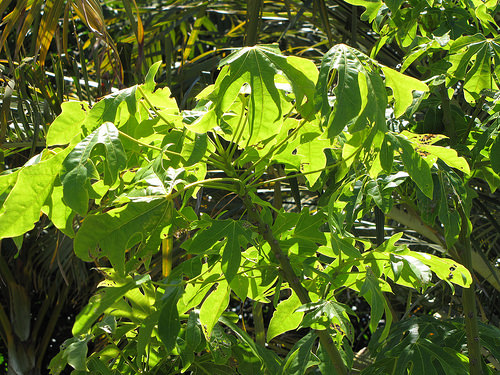<image>
Is the plant in front of the sunlight? No. The plant is not in front of the sunlight. The spatial positioning shows a different relationship between these objects. 